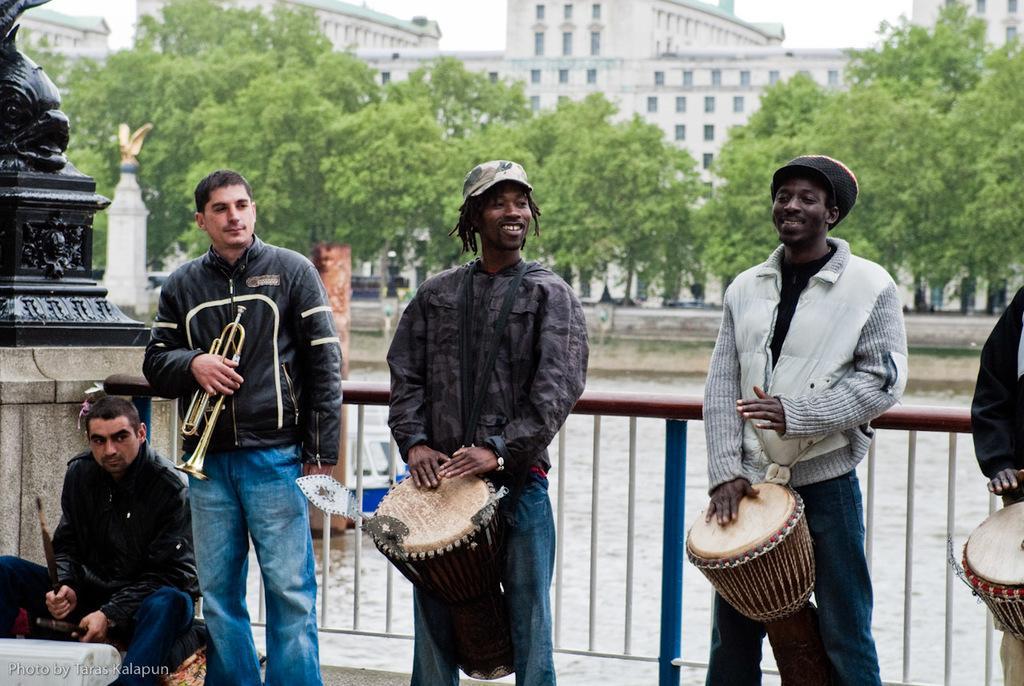Could you give a brief overview of what you see in this image? In this image there are group of persons playing musical instruments and at the background of the image there are trees and buildings and at the left side of the image there is a person sitting and beating drums. 